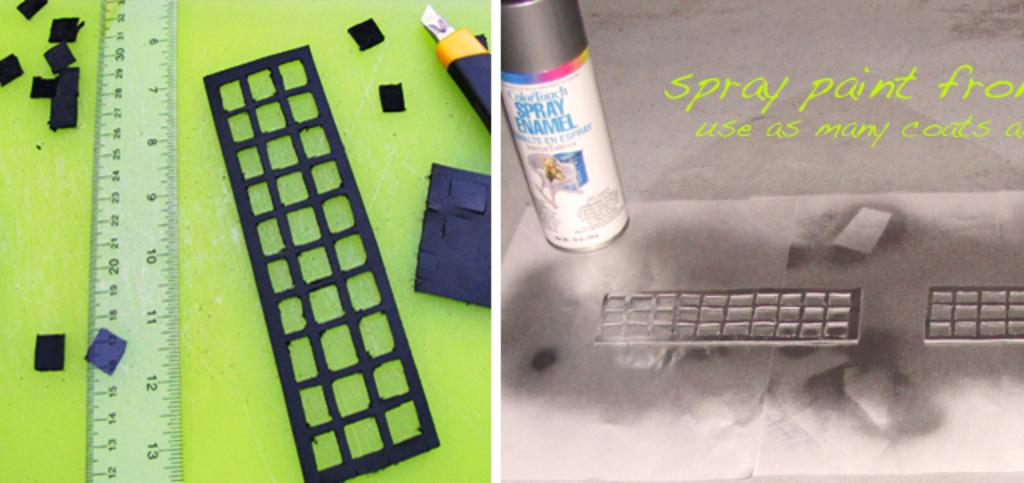<image>
Share a concise interpretation of the image provided. Spray enamel is used to paint a grid. 